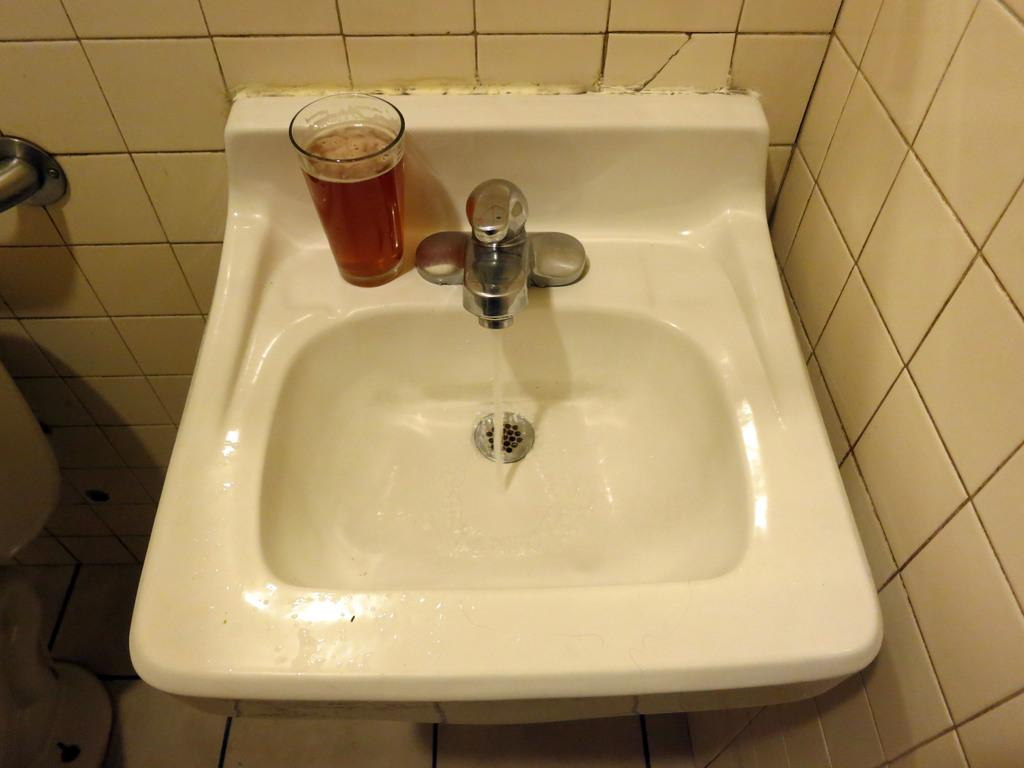What can be found in the image that is used for washing or filling with water? There is a sink with a tap in the image. What is placed near the sink in the image? There is a glass with liquid beside the sink in the image. What type of material covers the wall near the sink? There are tiles on the wall beside the sink. What type of crate is visible in the image? There is no crate present in the image. What action is being performed by the glass in the image? The glass is not performing any action; it is stationary beside the sink. 